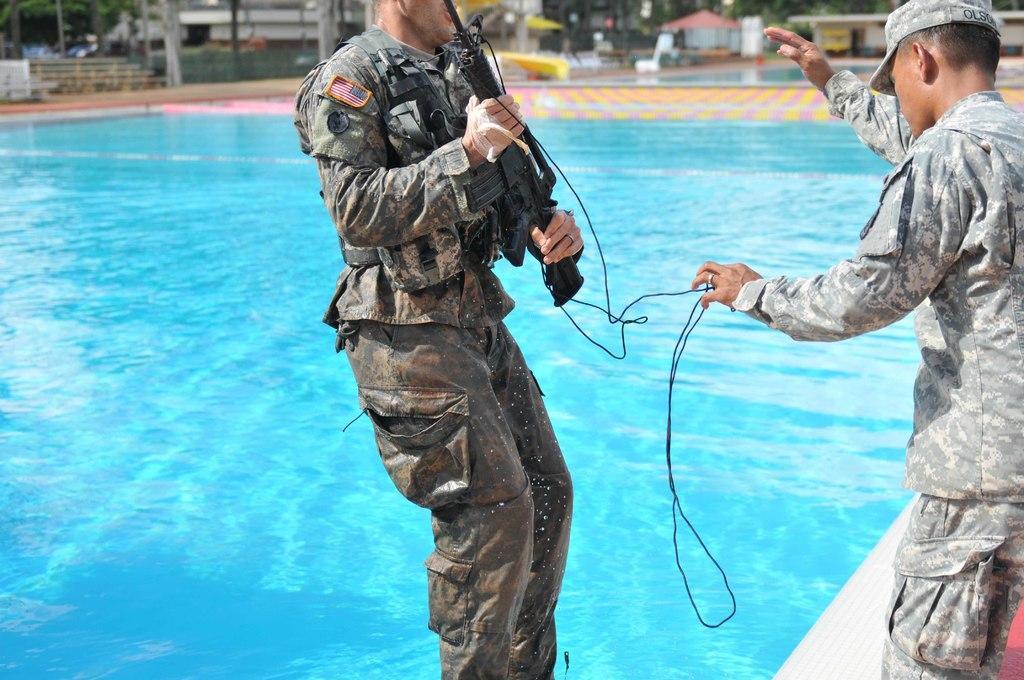Please provide a concise description of this image. In this picture there is a person standing and holding a gun in his hand and there is a swimming pool behind him and there is another person standing in the right corner and there are some other objects in the background. 